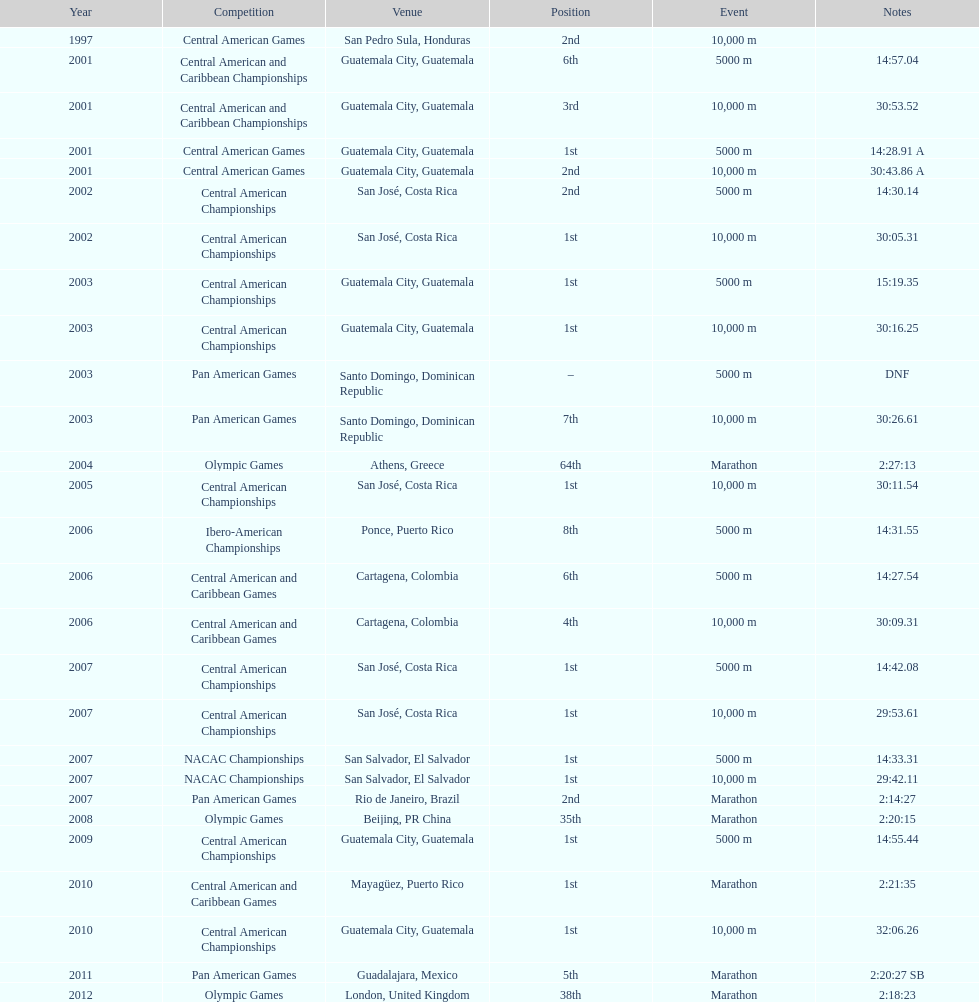What competition did this competitor compete at after participating in the central american games in 2001? Central American Championships. 